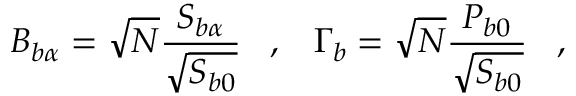<formula> <loc_0><loc_0><loc_500><loc_500>B _ { b \alpha } = \sqrt { N } \frac { S _ { b \alpha } } { \sqrt { S _ { b 0 } } } \, , \, \Gamma _ { b } = \sqrt { N } \frac { P _ { b 0 } } { \sqrt { S _ { b 0 } } } \, ,</formula> 